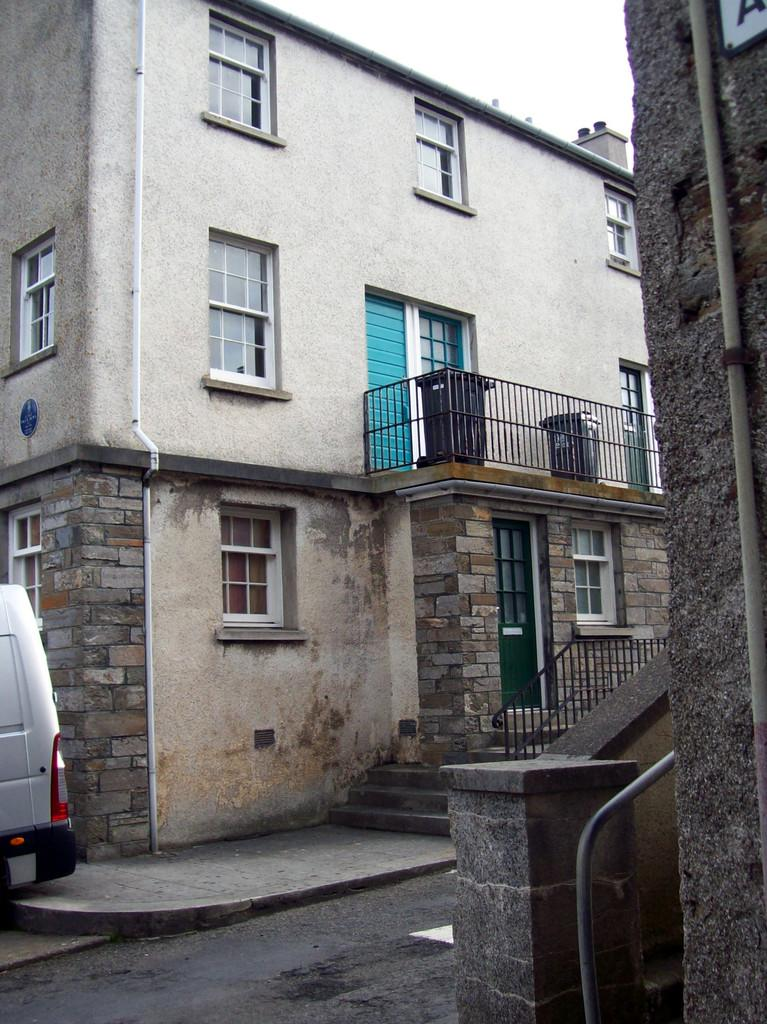What type of structures are present in the image? There are buildings in the image. What features can be observed on the buildings? The buildings have windows, pipes, iron grilles, and boards. Are there any architectural elements visible in the image? Yes, there are stairs in the image. What else can be seen in the image besides the buildings? There is a vehicle in the image. What is visible in the background of the image? The sky is visible in the image. What type of string is being used to hold up the metal spoon in the image? There is no string or metal spoon present in the image. 